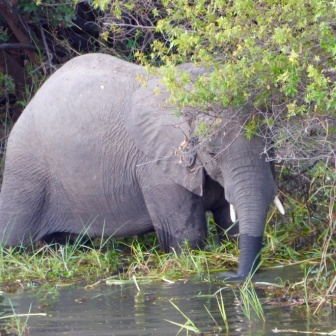What is the elephant doing in this image? The elephant appears to be foraging for food or drinking water. Its trunk is submerged in the water, likely searching for aquatic plants or taking a sip. 